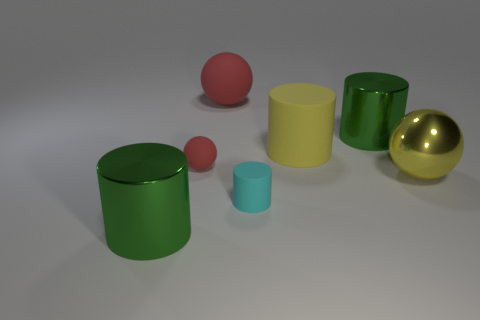How many objects are green metal cylinders behind the large yellow shiny ball or balls to the left of the cyan matte thing? There are two green metal cylinders situated behind the large yellow shiny sphere. If you're looking for the positioning relative to the cyan matte object, the cylinders are indeed to its left, reiterating that there are two such cylinders in view. 